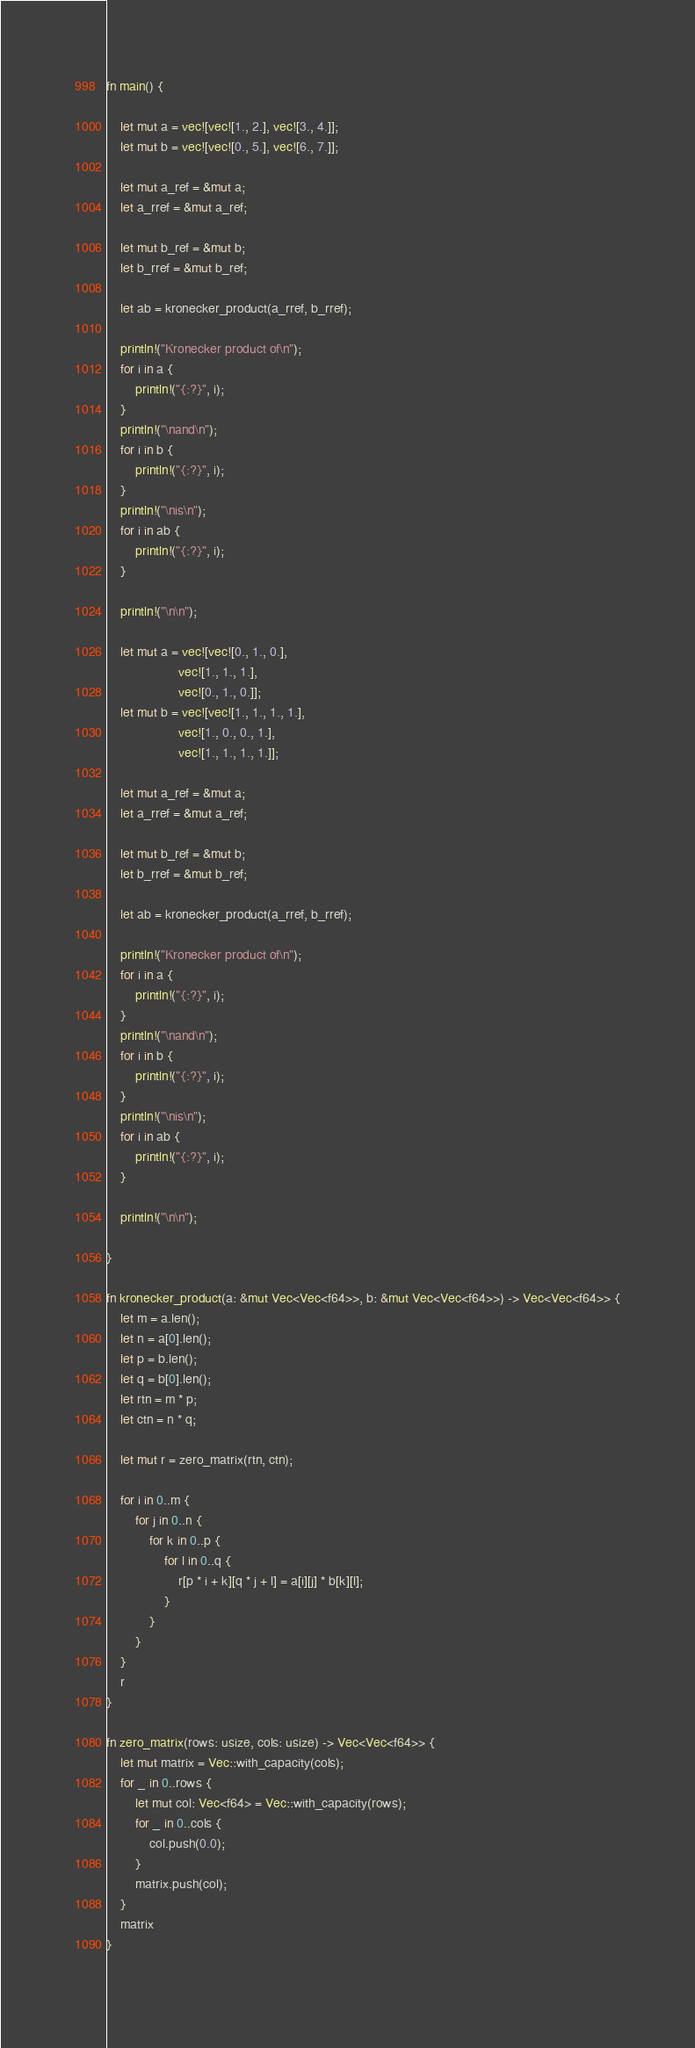Convert code to text. <code><loc_0><loc_0><loc_500><loc_500><_Rust_>fn main() {
 
    let mut a = vec![vec![1., 2.], vec![3., 4.]];
    let mut b = vec![vec![0., 5.], vec![6., 7.]];
 
    let mut a_ref = &mut a;
    let a_rref = &mut a_ref;
 
    let mut b_ref = &mut b;
    let b_rref = &mut b_ref;
 
    let ab = kronecker_product(a_rref, b_rref);
 
    println!("Kronecker product of\n");
    for i in a {
        println!("{:?}", i);
    }
    println!("\nand\n");
    for i in b {
        println!("{:?}", i);
    }
    println!("\nis\n");
    for i in ab {
        println!("{:?}", i);
    }
 
    println!("\n\n");
 
    let mut a = vec![vec![0., 1., 0.],
                    vec![1., 1., 1.],
                    vec![0., 1., 0.]];
    let mut b = vec![vec![1., 1., 1., 1.],
                    vec![1., 0., 0., 1.],
                    vec![1., 1., 1., 1.]];
 
    let mut a_ref = &mut a;
    let a_rref = &mut a_ref;
 
    let mut b_ref = &mut b;
    let b_rref = &mut b_ref;
 
    let ab = kronecker_product(a_rref, b_rref);
 
    println!("Kronecker product of\n");
    for i in a {
        println!("{:?}", i);
    }
    println!("\nand\n");
    for i in b {
        println!("{:?}", i);
    }
    println!("\nis\n");
    for i in ab {
        println!("{:?}", i);
    }
 
    println!("\n\n");
 
}
 
fn kronecker_product(a: &mut Vec<Vec<f64>>, b: &mut Vec<Vec<f64>>) -> Vec<Vec<f64>> {
    let m = a.len();
    let n = a[0].len();
    let p = b.len();
    let q = b[0].len();
    let rtn = m * p;
    let ctn = n * q;
 
    let mut r = zero_matrix(rtn, ctn);
 
    for i in 0..m {
        for j in 0..n {
            for k in 0..p {
                for l in 0..q {
                    r[p * i + k][q * j + l] = a[i][j] * b[k][l];
                }
            }
        }
    }
    r
}
 
fn zero_matrix(rows: usize, cols: usize) -> Vec<Vec<f64>> {
    let mut matrix = Vec::with_capacity(cols);
    for _ in 0..rows {
        let mut col: Vec<f64> = Vec::with_capacity(rows);
        for _ in 0..cols {
            col.push(0.0);
        }
        matrix.push(col);
    }
    matrix
}
 </code> 